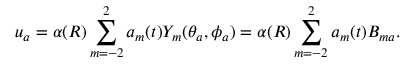<formula> <loc_0><loc_0><loc_500><loc_500>u _ { a } = \alpha ( R ) \sum _ { m = - 2 } ^ { 2 } a _ { m } ( t ) Y _ { m } ( \theta _ { a } , \phi _ { a } ) = \alpha ( R ) \sum _ { m = - 2 } ^ { 2 } a _ { m } ( t ) B _ { m a } .</formula> 